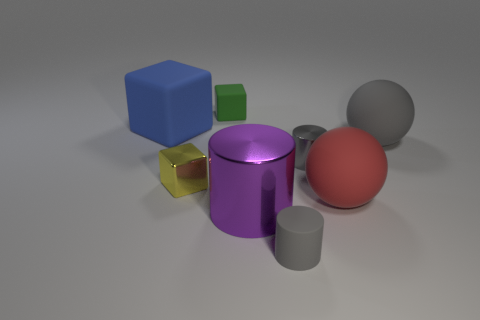Add 2 purple shiny objects. How many objects exist? 10 Subtract all cylinders. How many objects are left? 5 Add 3 gray cylinders. How many gray cylinders are left? 5 Add 3 cyan matte cylinders. How many cyan matte cylinders exist? 3 Subtract 1 gray spheres. How many objects are left? 7 Subtract all yellow matte things. Subtract all small green blocks. How many objects are left? 7 